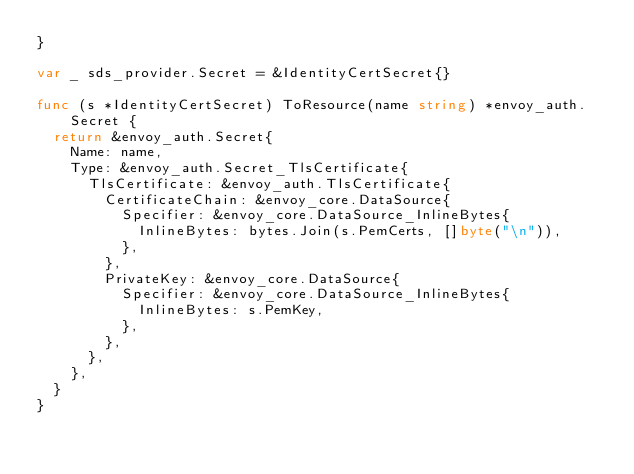<code> <loc_0><loc_0><loc_500><loc_500><_Go_>}

var _ sds_provider.Secret = &IdentityCertSecret{}

func (s *IdentityCertSecret) ToResource(name string) *envoy_auth.Secret {
	return &envoy_auth.Secret{
		Name: name,
		Type: &envoy_auth.Secret_TlsCertificate{
			TlsCertificate: &envoy_auth.TlsCertificate{
				CertificateChain: &envoy_core.DataSource{
					Specifier: &envoy_core.DataSource_InlineBytes{
						InlineBytes: bytes.Join(s.PemCerts, []byte("\n")),
					},
				},
				PrivateKey: &envoy_core.DataSource{
					Specifier: &envoy_core.DataSource_InlineBytes{
						InlineBytes: s.PemKey,
					},
				},
			},
		},
	}
}
</code> 